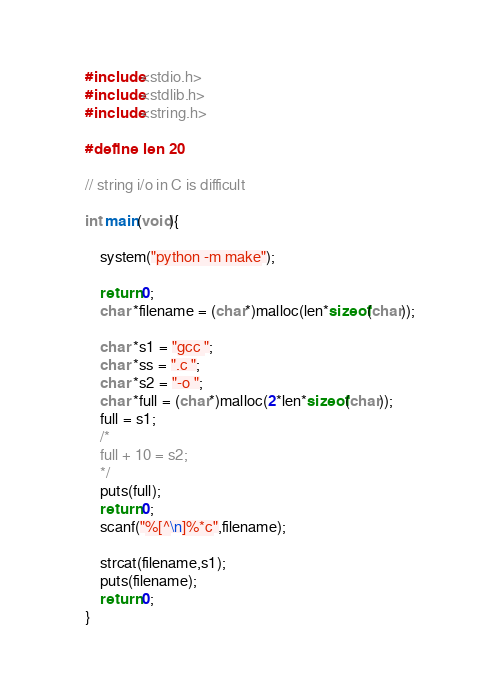Convert code to text. <code><loc_0><loc_0><loc_500><loc_500><_C_>#include<stdio.h>
#include<stdlib.h>
#include<string.h>

#define len 20 

// string i/o in C is difficult

int main(void){

	system("python -m make");

	return 0;
	char *filename = (char*)malloc(len*sizeof(char));

	char *s1 = "gcc ";
	char *ss = ".c ";
	char *s2 = "-o ";
	char *full = (char*)malloc(2*len*sizeof(char));
	full = s1;
	/*
	full + 10 = s2;
	*/
	puts(full);
	return 0;
	scanf("%[^\n]%*c",filename);
	
	strcat(filename,s1);
	puts(filename);
	return 0;
}
</code> 